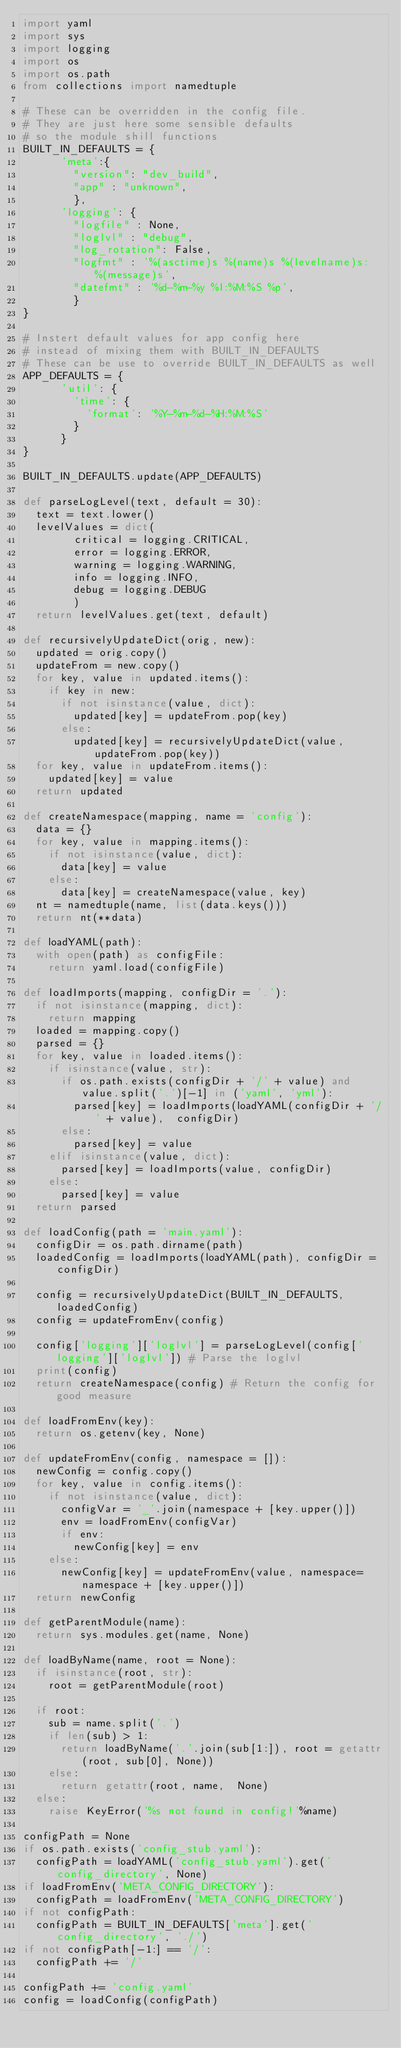<code> <loc_0><loc_0><loc_500><loc_500><_Python_>import yaml
import sys
import logging
import os
import os.path
from collections import namedtuple

# These can be overridden in the config file. 
# They are just here some sensible defaults
# so the module shill functions
BUILT_IN_DEFAULTS = { 
			'meta':{
				"version": "dev_build",
				"app" : "unknown",
				},
			'logging': {
				"logfile" : None,
				"loglvl" : "debug",
				"log_rotation": False,
				"logfmt" : '%(asctime)s %(name)s %(levelname)s: %(message)s',
				"datefmt" : '%d-%m-%y %I:%M:%S %p',
				}
}

# Instert default values for app config here 
# instead of mixing them with BUILT_IN_DEFAULTS
# These can be use to override BUILT_IN_DEFAULTS as well
APP_DEFAULTS = {
			'util': {
				'time': {
					'format': '%Y-%m-%d-%H:%M:%S'
				}
			}
}

BUILT_IN_DEFAULTS.update(APP_DEFAULTS)

def parseLogLevel(text, default = 30):
	text = text.lower()
	levelValues = dict(
				critical = logging.CRITICAL,
				error = logging.ERROR,
				warning = logging.WARNING,
				info = logging.INFO,
				debug = logging.DEBUG
				)
	return levelValues.get(text, default)

def recursivelyUpdateDict(orig, new):
	updated = orig.copy()
	updateFrom = new.copy()
	for key, value in updated.items():
		if key in new:
			if not isinstance(value, dict):
				updated[key] = updateFrom.pop(key)
			else:
				updated[key] = recursivelyUpdateDict(value, updateFrom.pop(key))
	for key, value in updateFrom.items():
		updated[key] = value
	return updated

def createNamespace(mapping, name = 'config'):
	data = {}
	for key, value in mapping.items():
		if not isinstance(value, dict):
			data[key] = value
		else:
			data[key] = createNamespace(value, key)
	nt = namedtuple(name, list(data.keys()))
	return nt(**data)

def loadYAML(path):
	with open(path) as configFile:
 		return yaml.load(configFile)

def loadImports(mapping, configDir = '.'):
	if not isinstance(mapping, dict):
		return mapping
	loaded = mapping.copy()
	parsed = {}
	for key, value in loaded.items():
		if isinstance(value, str):
			if os.path.exists(configDir + '/' + value) and value.split('.')[-1] in ('yaml', 'yml'):
				parsed[key] = loadImports(loadYAML(configDir + '/' + value),  configDir)
			else:
				parsed[key] = value
		elif isinstance(value, dict):
			parsed[key] = loadImports(value, configDir)
		else:
			parsed[key] = value
	return parsed

def loadConfig(path = 'main.yaml'):
	configDir = os.path.dirname(path)
	loadedConfig = loadImports(loadYAML(path), configDir = configDir)

	config = recursivelyUpdateDict(BUILT_IN_DEFAULTS, loadedConfig)
	config = updateFromEnv(config)

	config['logging']['loglvl'] = parseLogLevel(config['logging']['loglvl']) # Parse the loglvl
	print(config)
	return createNamespace(config) # Return the config for good measure

def loadFromEnv(key):
	return os.getenv(key, None)
	
def updateFromEnv(config, namespace = []):
	newConfig = config.copy()
	for key, value in config.items():
		if not isinstance(value, dict):
			configVar = '_'.join(namespace + [key.upper()])
			env = loadFromEnv(configVar)
			if env:
				newConfig[key] = env
		else:
			newConfig[key] = updateFromEnv(value, namespace=namespace + [key.upper()])
	return newConfig

def getParentModule(name):
	return sys.modules.get(name, None)

def loadByName(name, root = None):
	if isinstance(root, str):
		root = getParentModule(root)

	if root:
		sub = name.split('.')
		if len(sub) > 1:
			return loadByName('.'.join(sub[1:]), root = getattr(root, sub[0], None))
		else:
			return getattr(root, name,  None)
	else:
		raise KeyError('%s not found in config!'%name)

configPath = None
if os.path.exists('config_stub.yaml'):
	configPath = loadYAML('config_stub.yaml').get('config_directory', None)
if loadFromEnv('META_CONFIG_DIRECTORY'):
	configPath = loadFromEnv('META_CONFIG_DIRECTORY')
if not configPath:
	configPath = BUILT_IN_DEFAULTS['meta'].get('config_directory', './')
if not configPath[-1:] == '/':
	configPath += '/'

configPath += 'config.yaml'
config = loadConfig(configPath)
</code> 